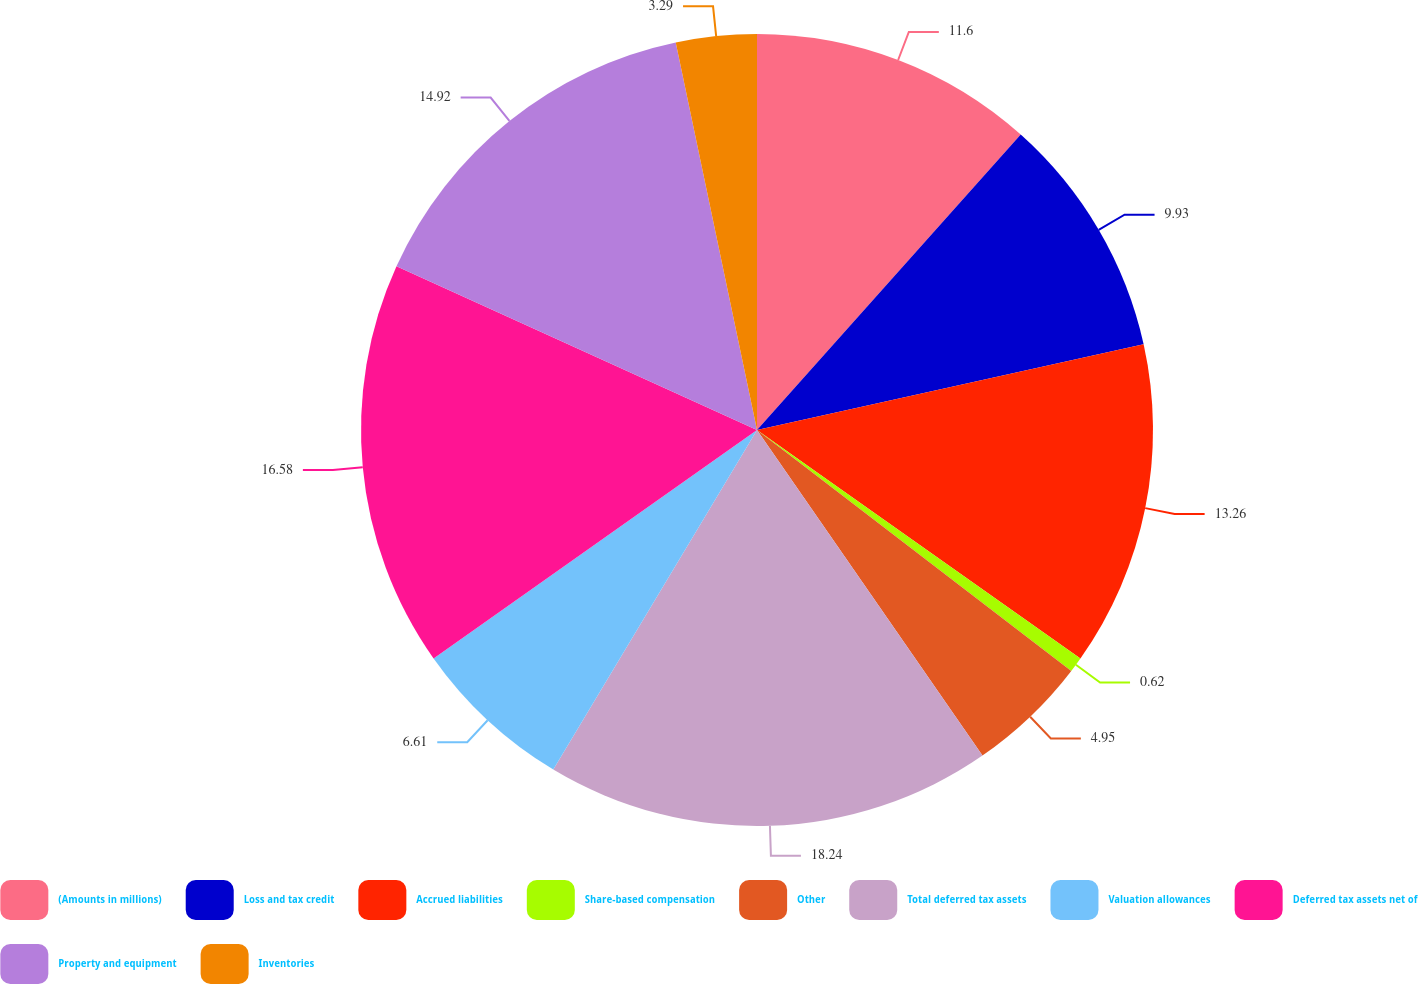Convert chart. <chart><loc_0><loc_0><loc_500><loc_500><pie_chart><fcel>(Amounts in millions)<fcel>Loss and tax credit<fcel>Accrued liabilities<fcel>Share-based compensation<fcel>Other<fcel>Total deferred tax assets<fcel>Valuation allowances<fcel>Deferred tax assets net of<fcel>Property and equipment<fcel>Inventories<nl><fcel>11.6%<fcel>9.93%<fcel>13.26%<fcel>0.62%<fcel>4.95%<fcel>18.24%<fcel>6.61%<fcel>16.58%<fcel>14.92%<fcel>3.29%<nl></chart> 